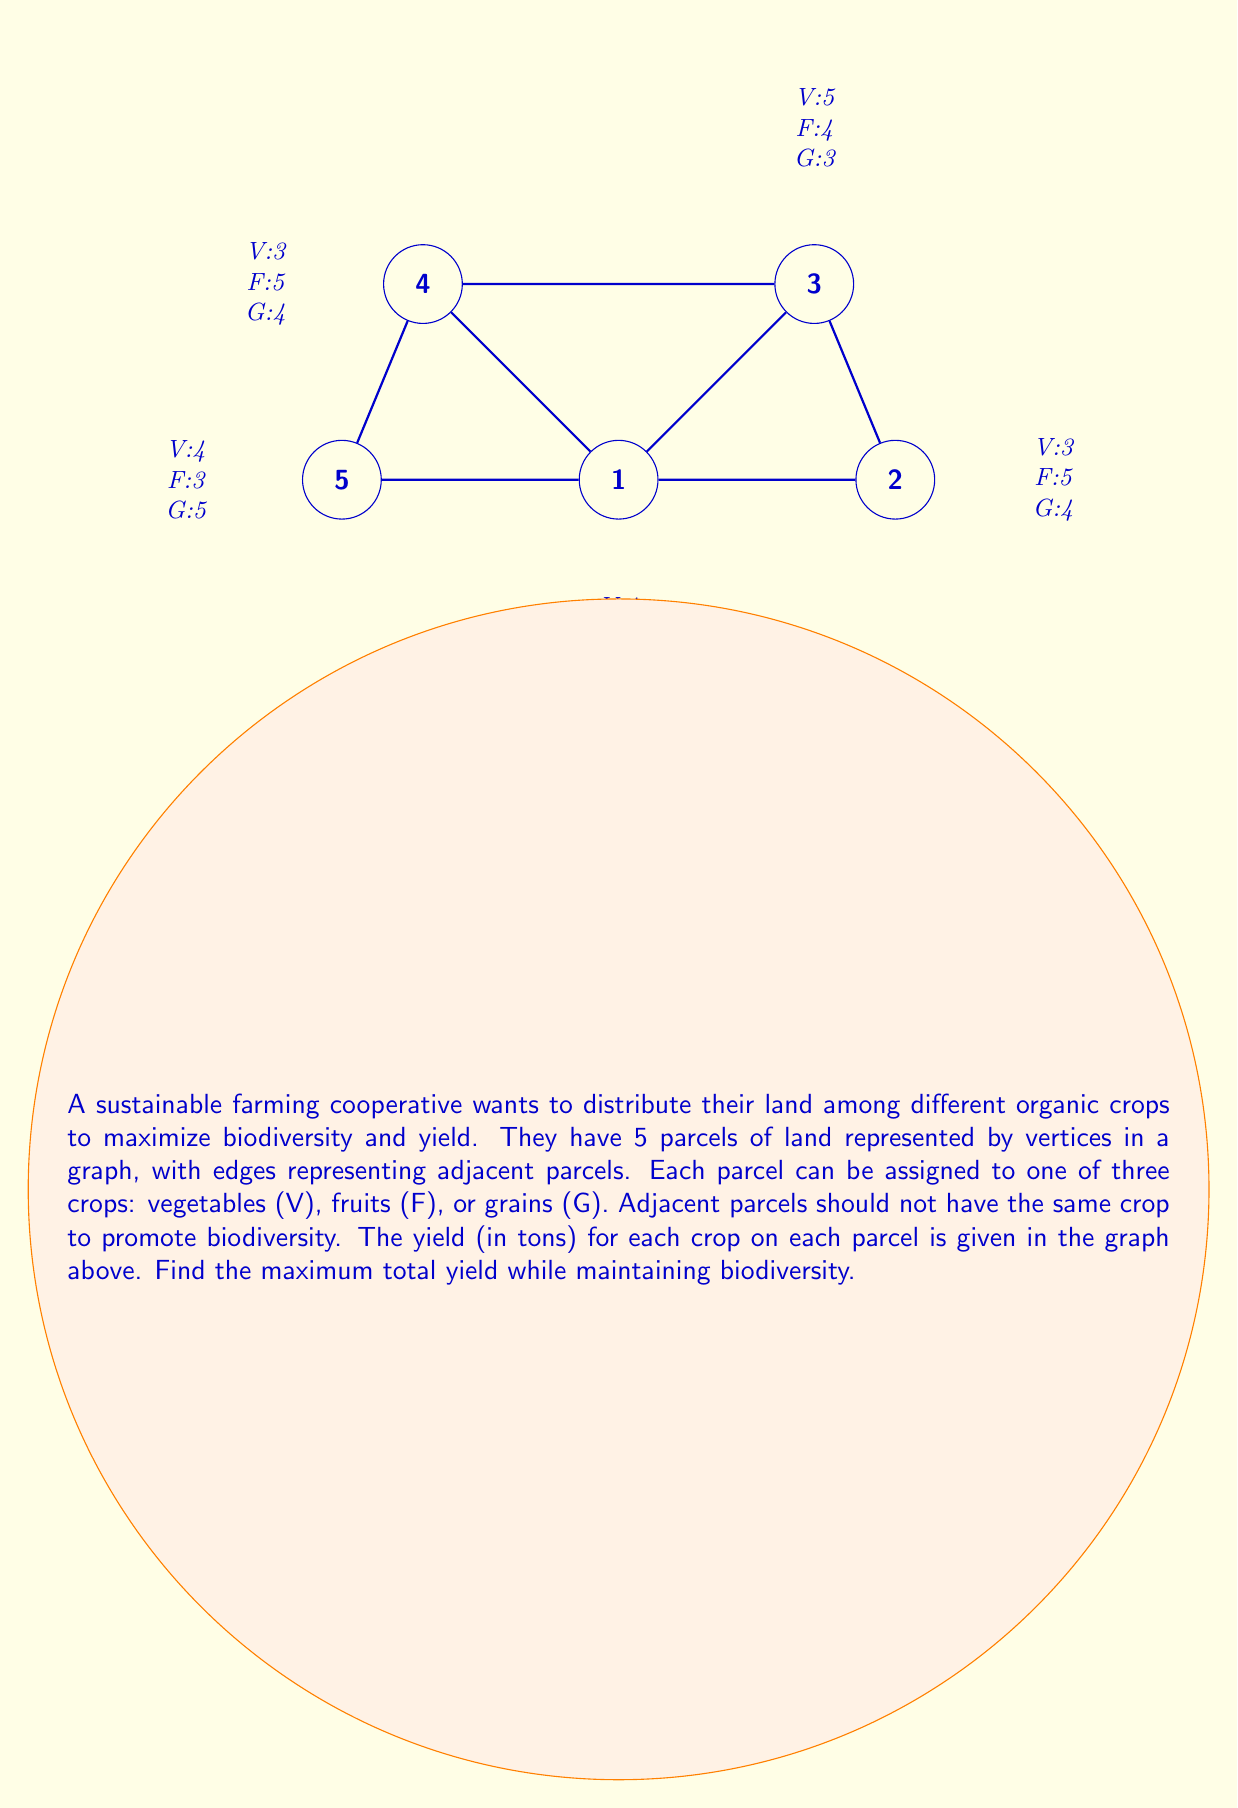Show me your answer to this math problem. To solve this problem, we'll use graph coloring techniques from graph theory, where each color represents a crop type. We need to find a 3-coloring of the graph that maximizes the total yield.

Step 1: Identify the constraints
- Each vertex (parcel) must be assigned one color (crop type)
- Adjacent vertices cannot have the same color
- We need to maximize the total yield

Step 2: List all possible valid colorings
Due to the symmetry of the graph, we can start by coloring vertex 1 and then consider all valid colorings. Let's use V, F, and G to represent the colors.

1. V-F-G-F-G
2. V-F-G-F-V
3. V-G-F-G-F
4. V-G-F-G-V

Step 3: Calculate the yield for each coloring
1. V-F-G-F-G: 4 + 5 + 3 + 5 + 5 = 22
2. V-F-G-F-V: 4 + 5 + 3 + 5 + 4 = 21
3. V-G-F-G-F: 4 + 4 + 4 + 4 + 3 = 19
4. V-G-F-G-V: 4 + 4 + 4 + 4 + 4 = 20

Step 4: Identify the maximum yield
The maximum yield is 22 tons, achieved by the coloring V-F-G-F-G.

Step 5: Verify the solution
- Each parcel is assigned one crop type
- No adjacent parcels have the same crop type
- The total yield is maximized at 22 tons
Answer: 22 tons with distribution V-F-G-F-G 